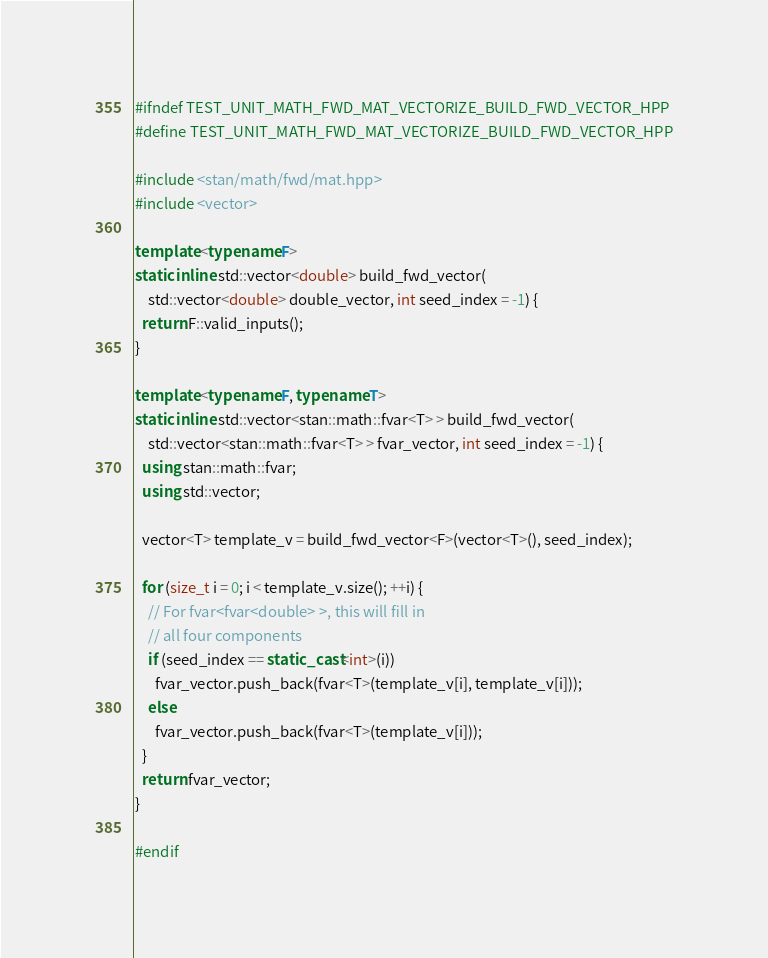<code> <loc_0><loc_0><loc_500><loc_500><_C++_>#ifndef TEST_UNIT_MATH_FWD_MAT_VECTORIZE_BUILD_FWD_VECTOR_HPP
#define TEST_UNIT_MATH_FWD_MAT_VECTORIZE_BUILD_FWD_VECTOR_HPP

#include <stan/math/fwd/mat.hpp>
#include <vector>

template <typename F>
static inline std::vector<double> build_fwd_vector(
    std::vector<double> double_vector, int seed_index = -1) {
  return F::valid_inputs();
}

template <typename F, typename T>
static inline std::vector<stan::math::fvar<T> > build_fwd_vector(
    std::vector<stan::math::fvar<T> > fvar_vector, int seed_index = -1) {
  using stan::math::fvar;
  using std::vector;

  vector<T> template_v = build_fwd_vector<F>(vector<T>(), seed_index);

  for (size_t i = 0; i < template_v.size(); ++i) {
    // For fvar<fvar<double> >, this will fill in
    // all four components
    if (seed_index == static_cast<int>(i))
      fvar_vector.push_back(fvar<T>(template_v[i], template_v[i]));
    else
      fvar_vector.push_back(fvar<T>(template_v[i]));
  }
  return fvar_vector;
}

#endif
</code> 